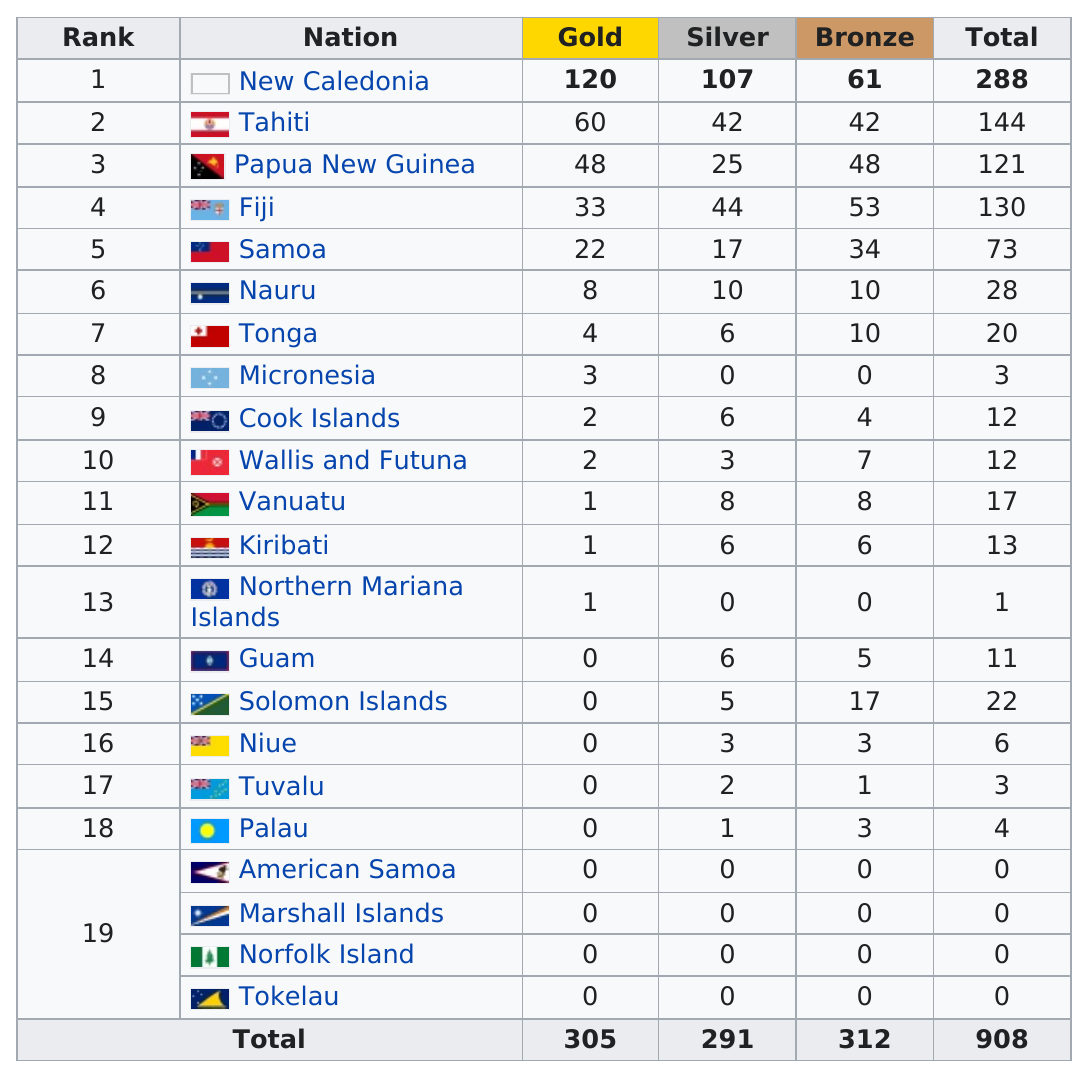Indicate a few pertinent items in this graphic. New Caledonia holds the top position in gold metal production, making it the leading country in this regard. The Cook Islands and Wallis and Futuna are two countries that both won two gold medals at the competition. Fiji and Tonga have varying medal counts, with Fiji having 110 medals and Tonga having [insert number of medals for Tonga]. New Caledonia is the nation with the most medals. New Caledonia has the most silver medals among all countries. 